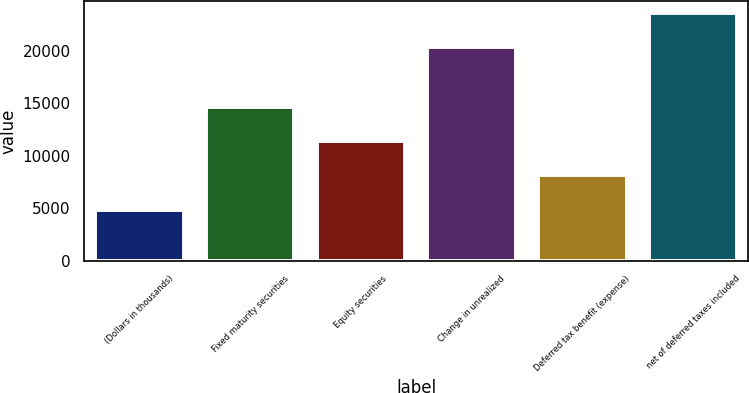<chart> <loc_0><loc_0><loc_500><loc_500><bar_chart><fcel>(Dollars in thousands)<fcel>Fixed maturity securities<fcel>Equity securities<fcel>Change in unrealized<fcel>Deferred tax benefit (expense)<fcel>net of deferred taxes included<nl><fcel>4885.2<fcel>14671.8<fcel>11409.6<fcel>20312<fcel>8147.4<fcel>23574.2<nl></chart> 